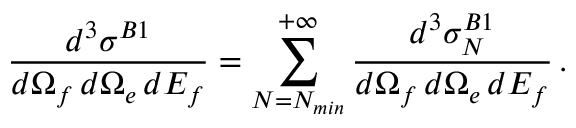Convert formula to latex. <formula><loc_0><loc_0><loc_500><loc_500>\frac { d ^ { 3 } { \sigma } ^ { B 1 } } { d \Omega _ { f } \, d \Omega _ { e } \, d E _ { f } } = \sum _ { N = N _ { \min } } ^ { + \infty } \frac { d ^ { 3 } { \sigma } _ { N } ^ { B 1 } } { d \Omega _ { f } \, d \Omega _ { e } \, d E _ { f } } \, .</formula> 